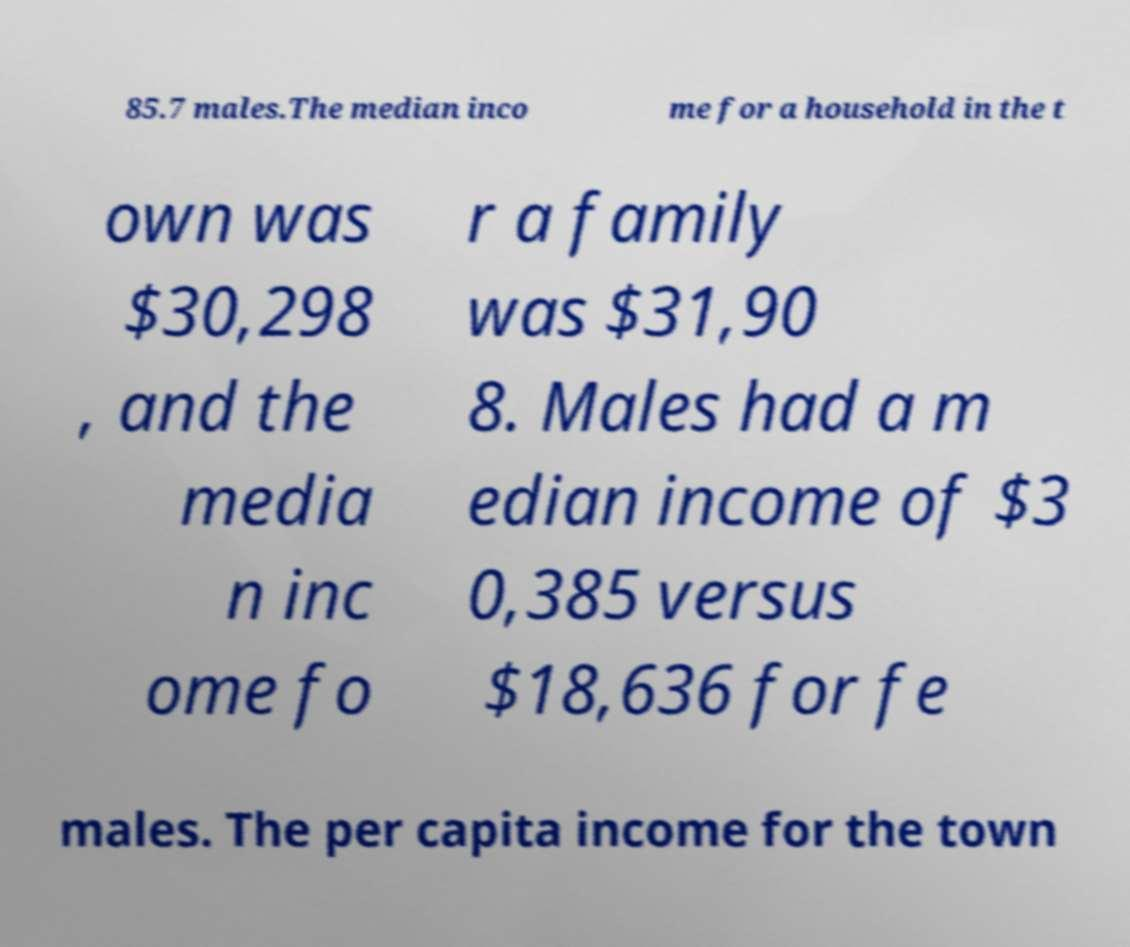Please read and relay the text visible in this image. What does it say? 85.7 males.The median inco me for a household in the t own was $30,298 , and the media n inc ome fo r a family was $31,90 8. Males had a m edian income of $3 0,385 versus $18,636 for fe males. The per capita income for the town 